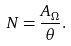Convert formula to latex. <formula><loc_0><loc_0><loc_500><loc_500>N = \frac { A _ { \Omega } } { \theta } .</formula> 